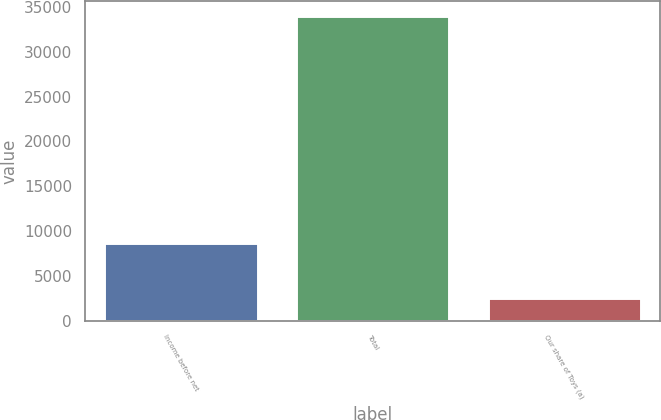Convert chart. <chart><loc_0><loc_0><loc_500><loc_500><bar_chart><fcel>Income before net<fcel>Total<fcel>Our share of Toys (a)<nl><fcel>8611<fcel>33964<fcel>2500<nl></chart> 